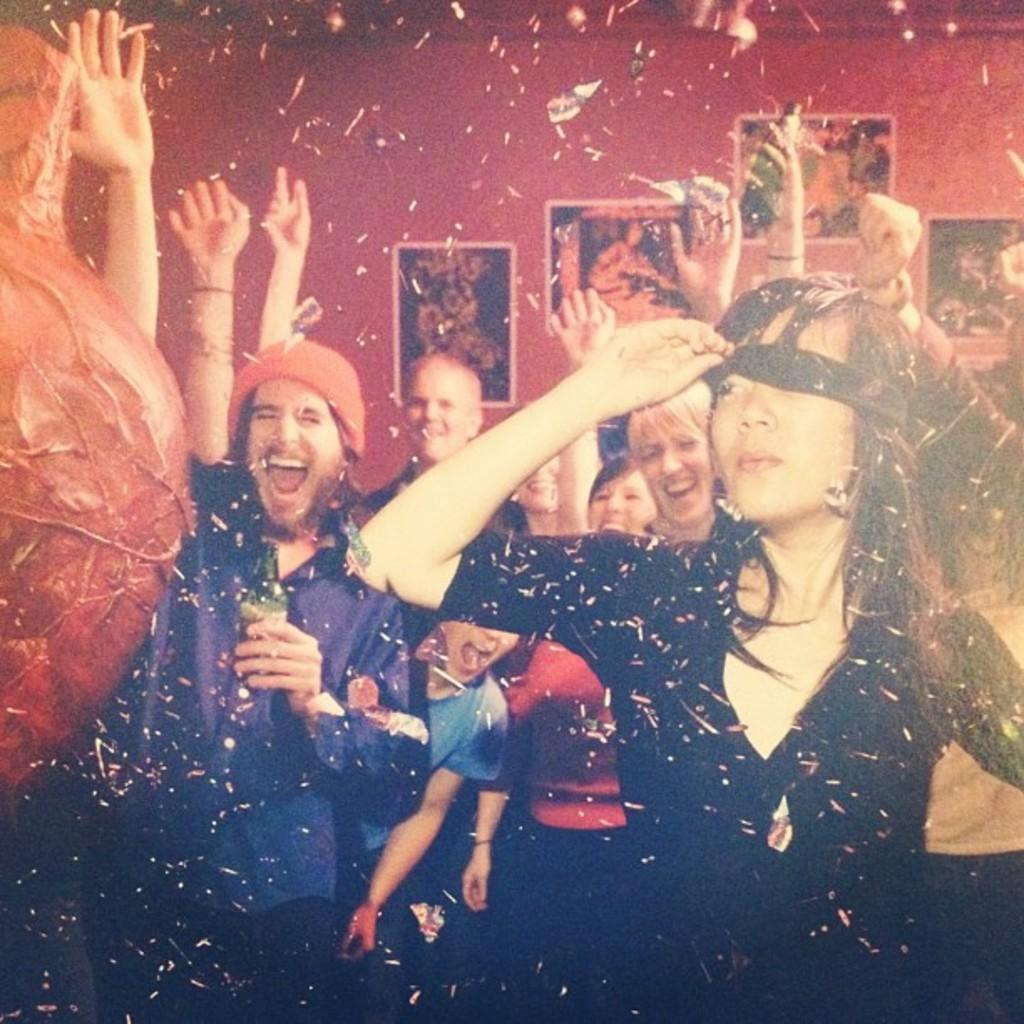How many people are in the image? There are people in the image, but the exact number is not specified. What is one person holding in the image? One person is holding a bottle in the image. What can be seen on the wall in the image? There are photo frames on the wall in the image. What type of items are visible on the surface in the image? There are papers visible in the image. What type of tail can be seen on the person in the image? There is no mention of a tail in the image. 